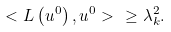Convert formula to latex. <formula><loc_0><loc_0><loc_500><loc_500>< L \left ( u ^ { 0 } \right ) , u ^ { 0 } > \ \geq \lambda _ { k } ^ { 2 } .</formula> 